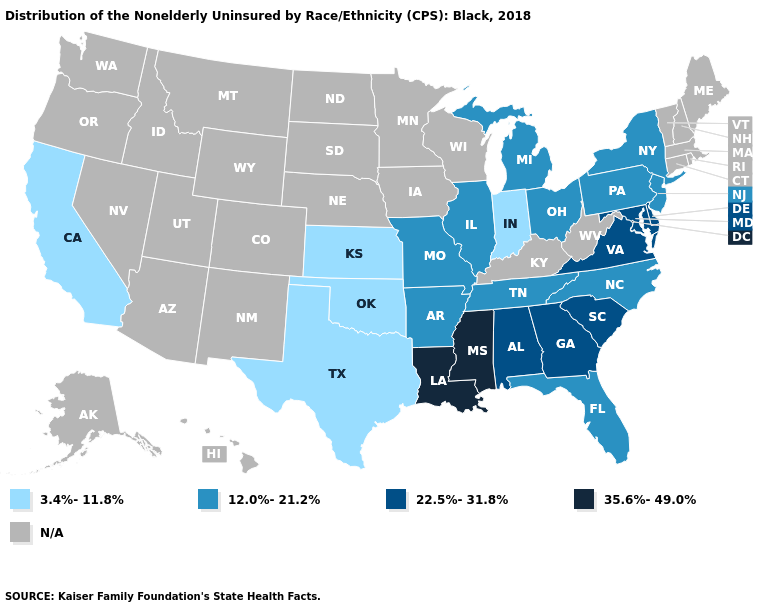Name the states that have a value in the range 35.6%-49.0%?
Answer briefly. Louisiana, Mississippi. Name the states that have a value in the range 22.5%-31.8%?
Short answer required. Alabama, Delaware, Georgia, Maryland, South Carolina, Virginia. Does Louisiana have the highest value in the USA?
Give a very brief answer. Yes. What is the highest value in the MidWest ?
Keep it brief. 12.0%-21.2%. Does Georgia have the lowest value in the USA?
Answer briefly. No. Does Georgia have the lowest value in the USA?
Be succinct. No. What is the value of Wisconsin?
Be succinct. N/A. Does Maryland have the lowest value in the USA?
Answer briefly. No. Does the map have missing data?
Concise answer only. Yes. What is the value of Georgia?
Concise answer only. 22.5%-31.8%. What is the value of Tennessee?
Answer briefly. 12.0%-21.2%. Which states hav the highest value in the MidWest?
Be succinct. Illinois, Michigan, Missouri, Ohio. What is the highest value in the USA?
Concise answer only. 35.6%-49.0%. Does the first symbol in the legend represent the smallest category?
Keep it brief. Yes. 